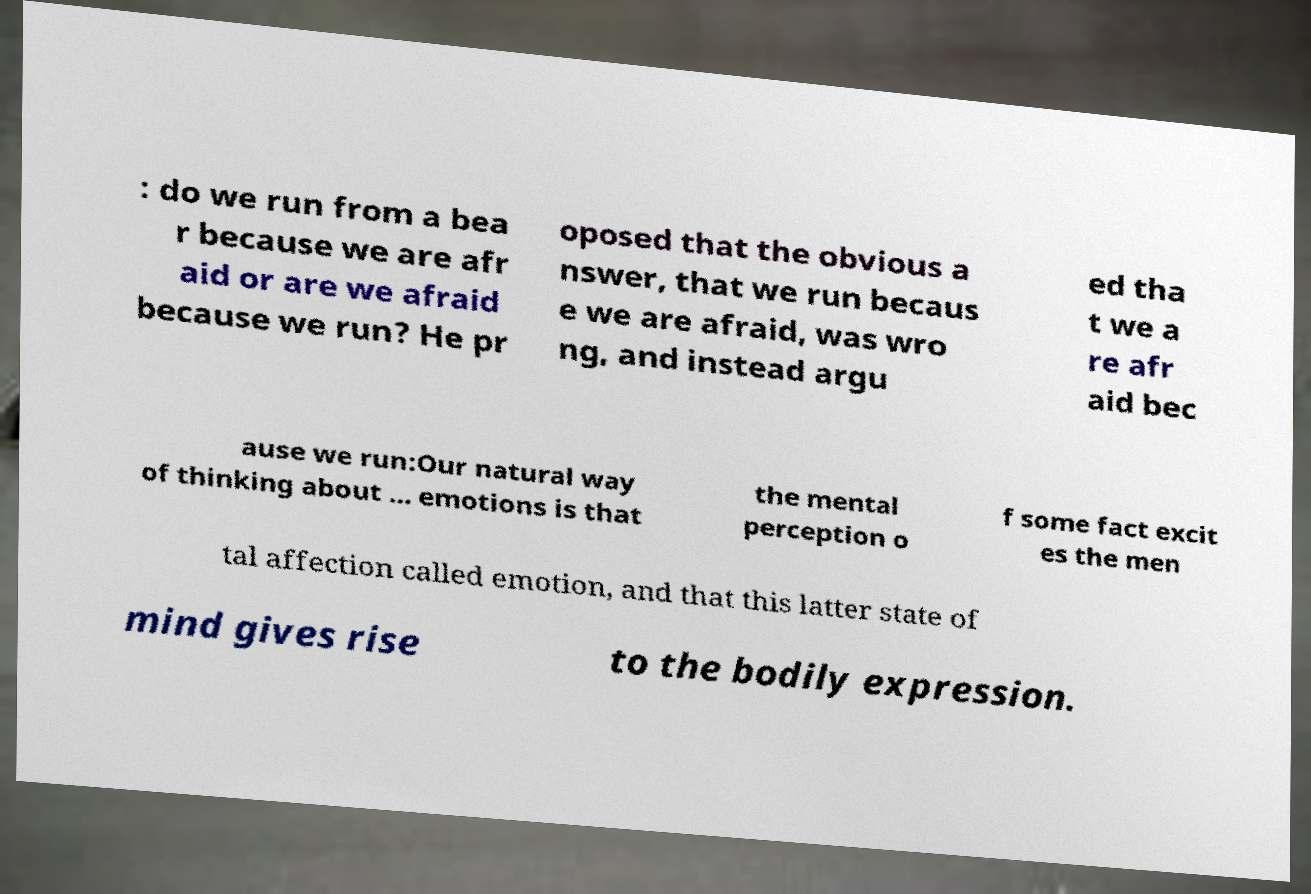Can you accurately transcribe the text from the provided image for me? : do we run from a bea r because we are afr aid or are we afraid because we run? He pr oposed that the obvious a nswer, that we run becaus e we are afraid, was wro ng, and instead argu ed tha t we a re afr aid bec ause we run:Our natural way of thinking about … emotions is that the mental perception o f some fact excit es the men tal affection called emotion, and that this latter state of mind gives rise to the bodily expression. 